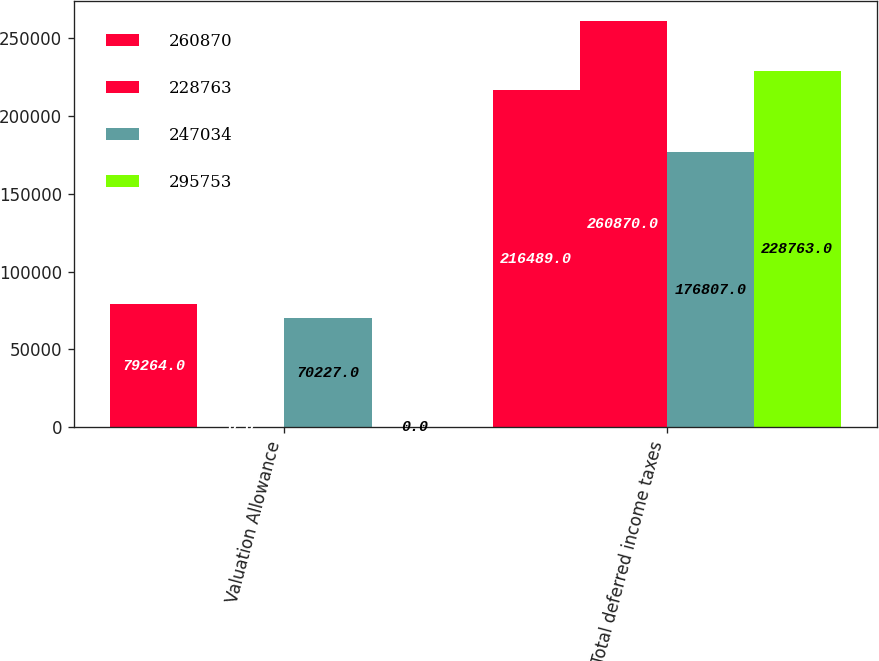<chart> <loc_0><loc_0><loc_500><loc_500><stacked_bar_chart><ecel><fcel>Valuation Allowance<fcel>Total deferred income taxes<nl><fcel>260870<fcel>79264<fcel>216489<nl><fcel>228763<fcel>0<fcel>260870<nl><fcel>247034<fcel>70227<fcel>176807<nl><fcel>295753<fcel>0<fcel>228763<nl></chart> 